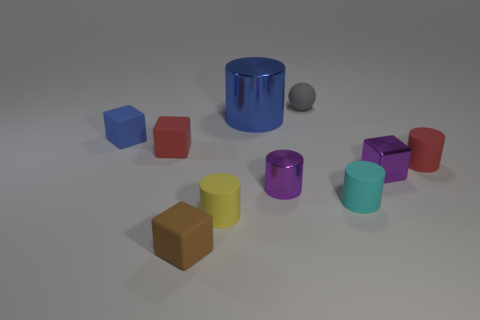Are there any other things of the same color as the big metal cylinder?
Ensure brevity in your answer.  Yes. There is a metallic object that is the same color as the shiny cube; what is its shape?
Provide a succinct answer. Cylinder. There is a rubber object to the right of the small purple block; what is its size?
Ensure brevity in your answer.  Small. The brown rubber thing that is the same size as the yellow cylinder is what shape?
Your response must be concise. Cube. Are the cube that is right of the big blue cylinder and the red object to the right of the tiny purple metal cylinder made of the same material?
Provide a succinct answer. No. The red thing that is on the left side of the shiny cylinder in front of the blue cube is made of what material?
Provide a succinct answer. Rubber. What is the size of the metal cylinder in front of the tiny red thing that is behind the red thing that is to the right of the brown block?
Keep it short and to the point. Small. Do the rubber sphere and the red rubber block have the same size?
Your answer should be very brief. Yes. Do the small metallic object that is on the left side of the small ball and the tiny yellow object that is right of the small blue matte object have the same shape?
Ensure brevity in your answer.  Yes. There is a metallic cylinder in front of the red cylinder; is there a small cyan object that is in front of it?
Provide a succinct answer. Yes. 